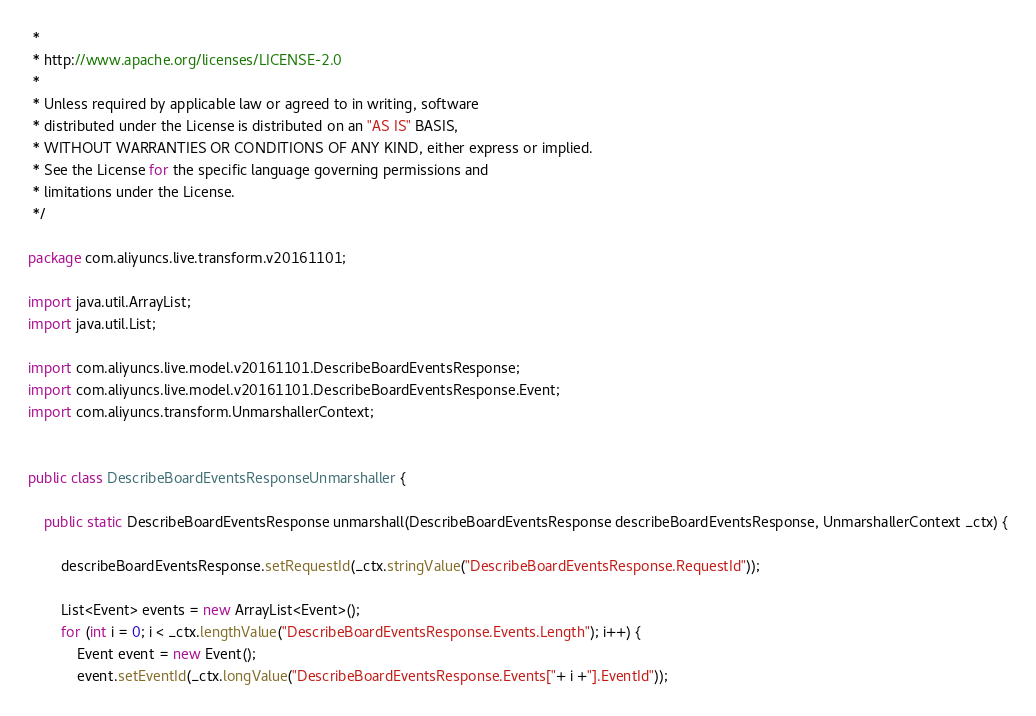Convert code to text. <code><loc_0><loc_0><loc_500><loc_500><_Java_> *
 * http://www.apache.org/licenses/LICENSE-2.0
 *
 * Unless required by applicable law or agreed to in writing, software
 * distributed under the License is distributed on an "AS IS" BASIS,
 * WITHOUT WARRANTIES OR CONDITIONS OF ANY KIND, either express or implied.
 * See the License for the specific language governing permissions and
 * limitations under the License.
 */

package com.aliyuncs.live.transform.v20161101;

import java.util.ArrayList;
import java.util.List;

import com.aliyuncs.live.model.v20161101.DescribeBoardEventsResponse;
import com.aliyuncs.live.model.v20161101.DescribeBoardEventsResponse.Event;
import com.aliyuncs.transform.UnmarshallerContext;


public class DescribeBoardEventsResponseUnmarshaller {

	public static DescribeBoardEventsResponse unmarshall(DescribeBoardEventsResponse describeBoardEventsResponse, UnmarshallerContext _ctx) {
		
		describeBoardEventsResponse.setRequestId(_ctx.stringValue("DescribeBoardEventsResponse.RequestId"));

		List<Event> events = new ArrayList<Event>();
		for (int i = 0; i < _ctx.lengthValue("DescribeBoardEventsResponse.Events.Length"); i++) {
			Event event = new Event();
			event.setEventId(_ctx.longValue("DescribeBoardEventsResponse.Events["+ i +"].EventId"));</code> 